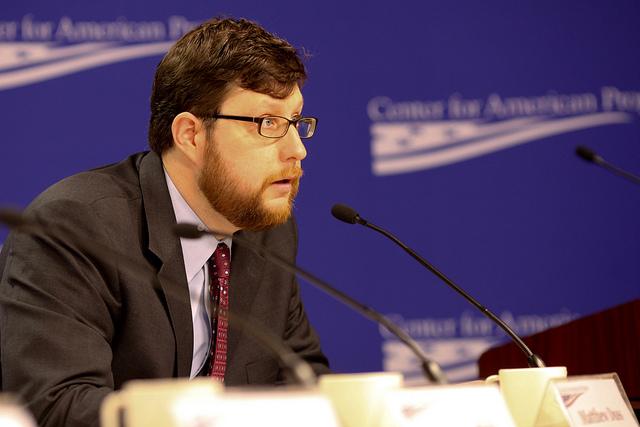What color is the gentleman's mustache?
Answer briefly. Brown. What does the man have on his face?
Be succinct. Glasses. Is he speaking into a microphone?
Short answer required. Yes. What color is the shirt of the men?
Short answer required. Blue. 